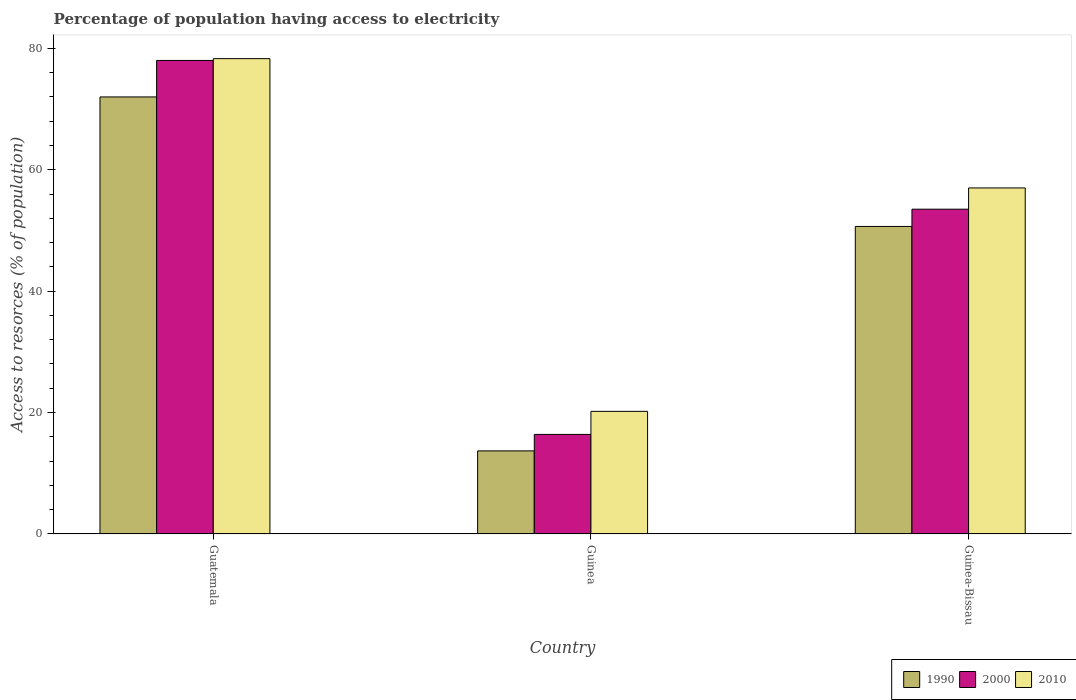Are the number of bars per tick equal to the number of legend labels?
Your answer should be very brief. Yes. How many bars are there on the 2nd tick from the right?
Make the answer very short. 3. What is the label of the 1st group of bars from the left?
Your answer should be very brief. Guatemala. What is the percentage of population having access to electricity in 1990 in Guatemala?
Give a very brief answer. 71.99. Across all countries, what is the maximum percentage of population having access to electricity in 1990?
Your response must be concise. 71.99. Across all countries, what is the minimum percentage of population having access to electricity in 1990?
Provide a succinct answer. 13.69. In which country was the percentage of population having access to electricity in 2000 maximum?
Make the answer very short. Guatemala. In which country was the percentage of population having access to electricity in 2010 minimum?
Give a very brief answer. Guinea. What is the total percentage of population having access to electricity in 2010 in the graph?
Give a very brief answer. 155.5. What is the difference between the percentage of population having access to electricity in 2010 in Guinea and that in Guinea-Bissau?
Provide a succinct answer. -36.8. What is the difference between the percentage of population having access to electricity in 2010 in Guatemala and the percentage of population having access to electricity in 2000 in Guinea?
Provide a succinct answer. 61.9. What is the average percentage of population having access to electricity in 2010 per country?
Your answer should be compact. 51.83. What is the difference between the percentage of population having access to electricity of/in 2010 and percentage of population having access to electricity of/in 1990 in Guinea?
Make the answer very short. 6.51. In how many countries, is the percentage of population having access to electricity in 1990 greater than 48 %?
Offer a terse response. 2. What is the ratio of the percentage of population having access to electricity in 1990 in Guatemala to that in Guinea?
Make the answer very short. 5.26. Is the percentage of population having access to electricity in 2010 in Guinea less than that in Guinea-Bissau?
Make the answer very short. Yes. What is the difference between the highest and the second highest percentage of population having access to electricity in 1990?
Keep it short and to the point. 36.97. What is the difference between the highest and the lowest percentage of population having access to electricity in 2000?
Offer a very short reply. 61.6. In how many countries, is the percentage of population having access to electricity in 2000 greater than the average percentage of population having access to electricity in 2000 taken over all countries?
Provide a succinct answer. 2. What does the 1st bar from the left in Guinea-Bissau represents?
Ensure brevity in your answer.  1990. How many bars are there?
Your answer should be very brief. 9. Are all the bars in the graph horizontal?
Give a very brief answer. No. Are the values on the major ticks of Y-axis written in scientific E-notation?
Offer a very short reply. No. Does the graph contain any zero values?
Give a very brief answer. No. What is the title of the graph?
Provide a short and direct response. Percentage of population having access to electricity. Does "1983" appear as one of the legend labels in the graph?
Your response must be concise. No. What is the label or title of the Y-axis?
Keep it short and to the point. Access to resorces (% of population). What is the Access to resorces (% of population) of 1990 in Guatemala?
Your answer should be very brief. 71.99. What is the Access to resorces (% of population) in 2010 in Guatemala?
Offer a very short reply. 78.3. What is the Access to resorces (% of population) of 1990 in Guinea?
Your answer should be compact. 13.69. What is the Access to resorces (% of population) of 2010 in Guinea?
Your answer should be very brief. 20.2. What is the Access to resorces (% of population) in 1990 in Guinea-Bissau?
Provide a succinct answer. 50.66. What is the Access to resorces (% of population) of 2000 in Guinea-Bissau?
Keep it short and to the point. 53.5. What is the Access to resorces (% of population) of 2010 in Guinea-Bissau?
Your response must be concise. 57. Across all countries, what is the maximum Access to resorces (% of population) in 1990?
Provide a succinct answer. 71.99. Across all countries, what is the maximum Access to resorces (% of population) of 2000?
Your answer should be very brief. 78. Across all countries, what is the maximum Access to resorces (% of population) in 2010?
Your response must be concise. 78.3. Across all countries, what is the minimum Access to resorces (% of population) of 1990?
Provide a succinct answer. 13.69. Across all countries, what is the minimum Access to resorces (% of population) of 2000?
Your answer should be compact. 16.4. Across all countries, what is the minimum Access to resorces (% of population) in 2010?
Make the answer very short. 20.2. What is the total Access to resorces (% of population) of 1990 in the graph?
Offer a very short reply. 136.34. What is the total Access to resorces (% of population) in 2000 in the graph?
Offer a terse response. 147.9. What is the total Access to resorces (% of population) of 2010 in the graph?
Ensure brevity in your answer.  155.5. What is the difference between the Access to resorces (% of population) of 1990 in Guatemala and that in Guinea?
Offer a terse response. 58.3. What is the difference between the Access to resorces (% of population) of 2000 in Guatemala and that in Guinea?
Keep it short and to the point. 61.6. What is the difference between the Access to resorces (% of population) of 2010 in Guatemala and that in Guinea?
Provide a short and direct response. 58.1. What is the difference between the Access to resorces (% of population) in 1990 in Guatemala and that in Guinea-Bissau?
Offer a terse response. 21.33. What is the difference between the Access to resorces (% of population) in 2010 in Guatemala and that in Guinea-Bissau?
Make the answer very short. 21.3. What is the difference between the Access to resorces (% of population) in 1990 in Guinea and that in Guinea-Bissau?
Give a very brief answer. -36.97. What is the difference between the Access to resorces (% of population) of 2000 in Guinea and that in Guinea-Bissau?
Offer a very short reply. -37.1. What is the difference between the Access to resorces (% of population) of 2010 in Guinea and that in Guinea-Bissau?
Your response must be concise. -36.8. What is the difference between the Access to resorces (% of population) of 1990 in Guatemala and the Access to resorces (% of population) of 2000 in Guinea?
Provide a short and direct response. 55.59. What is the difference between the Access to resorces (% of population) of 1990 in Guatemala and the Access to resorces (% of population) of 2010 in Guinea?
Your response must be concise. 51.79. What is the difference between the Access to resorces (% of population) in 2000 in Guatemala and the Access to resorces (% of population) in 2010 in Guinea?
Offer a terse response. 57.8. What is the difference between the Access to resorces (% of population) in 1990 in Guatemala and the Access to resorces (% of population) in 2000 in Guinea-Bissau?
Offer a terse response. 18.49. What is the difference between the Access to resorces (% of population) of 1990 in Guatemala and the Access to resorces (% of population) of 2010 in Guinea-Bissau?
Your answer should be compact. 14.99. What is the difference between the Access to resorces (% of population) of 1990 in Guinea and the Access to resorces (% of population) of 2000 in Guinea-Bissau?
Your answer should be compact. -39.81. What is the difference between the Access to resorces (% of population) in 1990 in Guinea and the Access to resorces (% of population) in 2010 in Guinea-Bissau?
Make the answer very short. -43.31. What is the difference between the Access to resorces (% of population) in 2000 in Guinea and the Access to resorces (% of population) in 2010 in Guinea-Bissau?
Offer a very short reply. -40.6. What is the average Access to resorces (% of population) in 1990 per country?
Provide a short and direct response. 45.45. What is the average Access to resorces (% of population) in 2000 per country?
Make the answer very short. 49.3. What is the average Access to resorces (% of population) in 2010 per country?
Make the answer very short. 51.83. What is the difference between the Access to resorces (% of population) of 1990 and Access to resorces (% of population) of 2000 in Guatemala?
Provide a short and direct response. -6.01. What is the difference between the Access to resorces (% of population) of 1990 and Access to resorces (% of population) of 2010 in Guatemala?
Give a very brief answer. -6.31. What is the difference between the Access to resorces (% of population) of 1990 and Access to resorces (% of population) of 2000 in Guinea?
Make the answer very short. -2.71. What is the difference between the Access to resorces (% of population) of 1990 and Access to resorces (% of population) of 2010 in Guinea?
Offer a very short reply. -6.51. What is the difference between the Access to resorces (% of population) of 1990 and Access to resorces (% of population) of 2000 in Guinea-Bissau?
Offer a terse response. -2.84. What is the difference between the Access to resorces (% of population) of 1990 and Access to resorces (% of population) of 2010 in Guinea-Bissau?
Your answer should be very brief. -6.34. What is the ratio of the Access to resorces (% of population) of 1990 in Guatemala to that in Guinea?
Your answer should be compact. 5.26. What is the ratio of the Access to resorces (% of population) of 2000 in Guatemala to that in Guinea?
Keep it short and to the point. 4.76. What is the ratio of the Access to resorces (% of population) of 2010 in Guatemala to that in Guinea?
Provide a short and direct response. 3.88. What is the ratio of the Access to resorces (% of population) of 1990 in Guatemala to that in Guinea-Bissau?
Offer a terse response. 1.42. What is the ratio of the Access to resorces (% of population) in 2000 in Guatemala to that in Guinea-Bissau?
Your answer should be very brief. 1.46. What is the ratio of the Access to resorces (% of population) of 2010 in Guatemala to that in Guinea-Bissau?
Make the answer very short. 1.37. What is the ratio of the Access to resorces (% of population) in 1990 in Guinea to that in Guinea-Bissau?
Your answer should be very brief. 0.27. What is the ratio of the Access to resorces (% of population) of 2000 in Guinea to that in Guinea-Bissau?
Offer a very short reply. 0.31. What is the ratio of the Access to resorces (% of population) in 2010 in Guinea to that in Guinea-Bissau?
Your answer should be compact. 0.35. What is the difference between the highest and the second highest Access to resorces (% of population) in 1990?
Your answer should be very brief. 21.33. What is the difference between the highest and the second highest Access to resorces (% of population) of 2010?
Give a very brief answer. 21.3. What is the difference between the highest and the lowest Access to resorces (% of population) of 1990?
Offer a terse response. 58.3. What is the difference between the highest and the lowest Access to resorces (% of population) in 2000?
Keep it short and to the point. 61.6. What is the difference between the highest and the lowest Access to resorces (% of population) of 2010?
Your answer should be very brief. 58.1. 